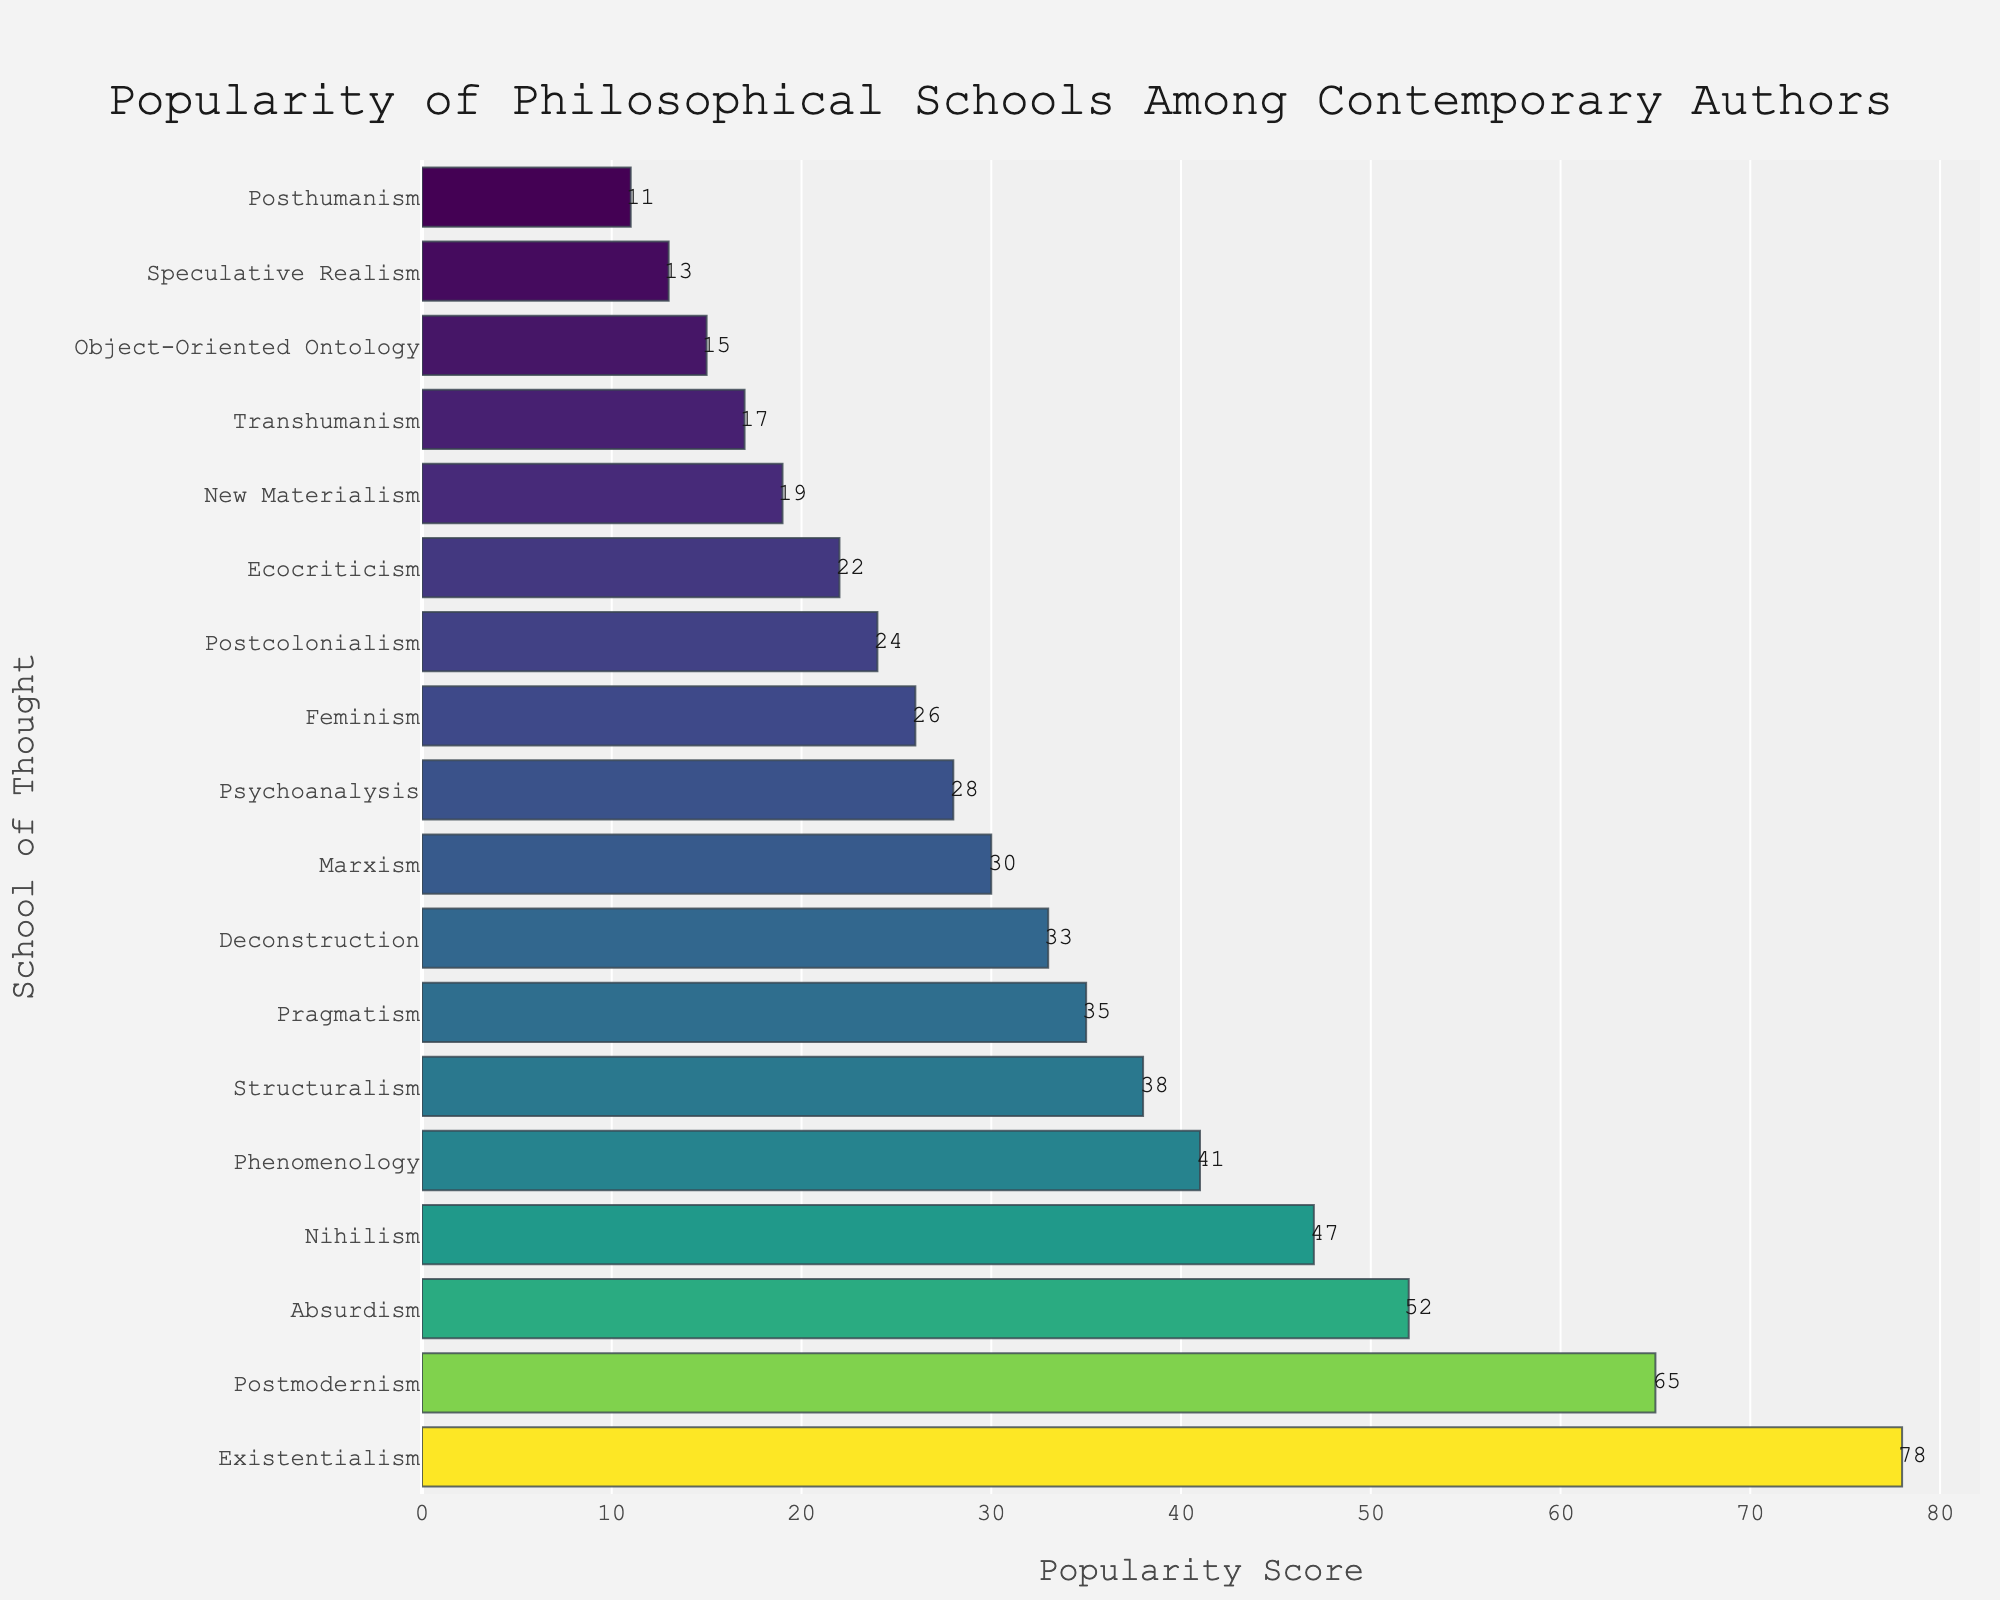Which school of thought is the most popular among contemporary authors? The most popular school of thought can be identified by the highest bar in the chart. Existentialism has the highest popularity score of 78.
Answer: Existentialism What is the combined popularity score for Existentialism, Postmodernism, and Absurdism? To find the combined popularity score, sum the popularity scores of the three schools: Existentialism (78) + Postmodernism (65) + Absurdism (52) = 195.
Answer: 195 Which two schools of thought have the smallest difference in popularity scores? By examining the chart, look for bars that are closest in length. Postcolonialism and Ecocriticism have popularity scores of 24 and 22, respectively, which differ by 2.
Answer: Postcolonialism and Ecocriticism How much more popular is Phenomenology than Feminism? Compare the popularity scores: Phenomenology has a score of 41, and Feminism has a score of 26. The difference is 41 - 26 = 15.
Answer: 15 Which school of thought has the lowest popularity among contemporary authors? The school of thought with the shortest bar and smallest popularity score is Posthumanism with a score of 11.
Answer: Posthumanism What is the average popularity score of the bottom five schools of thought? Identify and sum the popularity scores of the bottom five schools: New Materialism (19) + Transhumanism (17) + Object-Oriented Ontology (15) + Speculative Realism (13) + Posthumanism (11). The sum is 75, and the average is 75 / 5 = 15.
Answer: 15 Among the top five schools of thought, which one shows the greatest difference from Psychoanalysis? The top five schools are Existentialism (78), Postmodernism (65), Absurdism (52), Nihilism (47), and Phenomenology (41). Psychoanalysis has a score of 28. The largest difference is with Existentialism: 78 - 28 = 50.
Answer: Existentialism How many schools of thought have a popularity score greater than 30? Count the number of bars with scores above 30: Existentialism, Postmodernism, Absurdism, Nihilism, Phenomenology, Structuralism, Pragmatism, Deconstruction, and Marxism, totaling 9.
Answer: 9 What is the difference between the highest and lowest popularity scores? The highest popularity score is 78 (Existentialism) and the lowest is 11 (Posthumanism). The difference is 78 - 11 = 67.
Answer: 67 